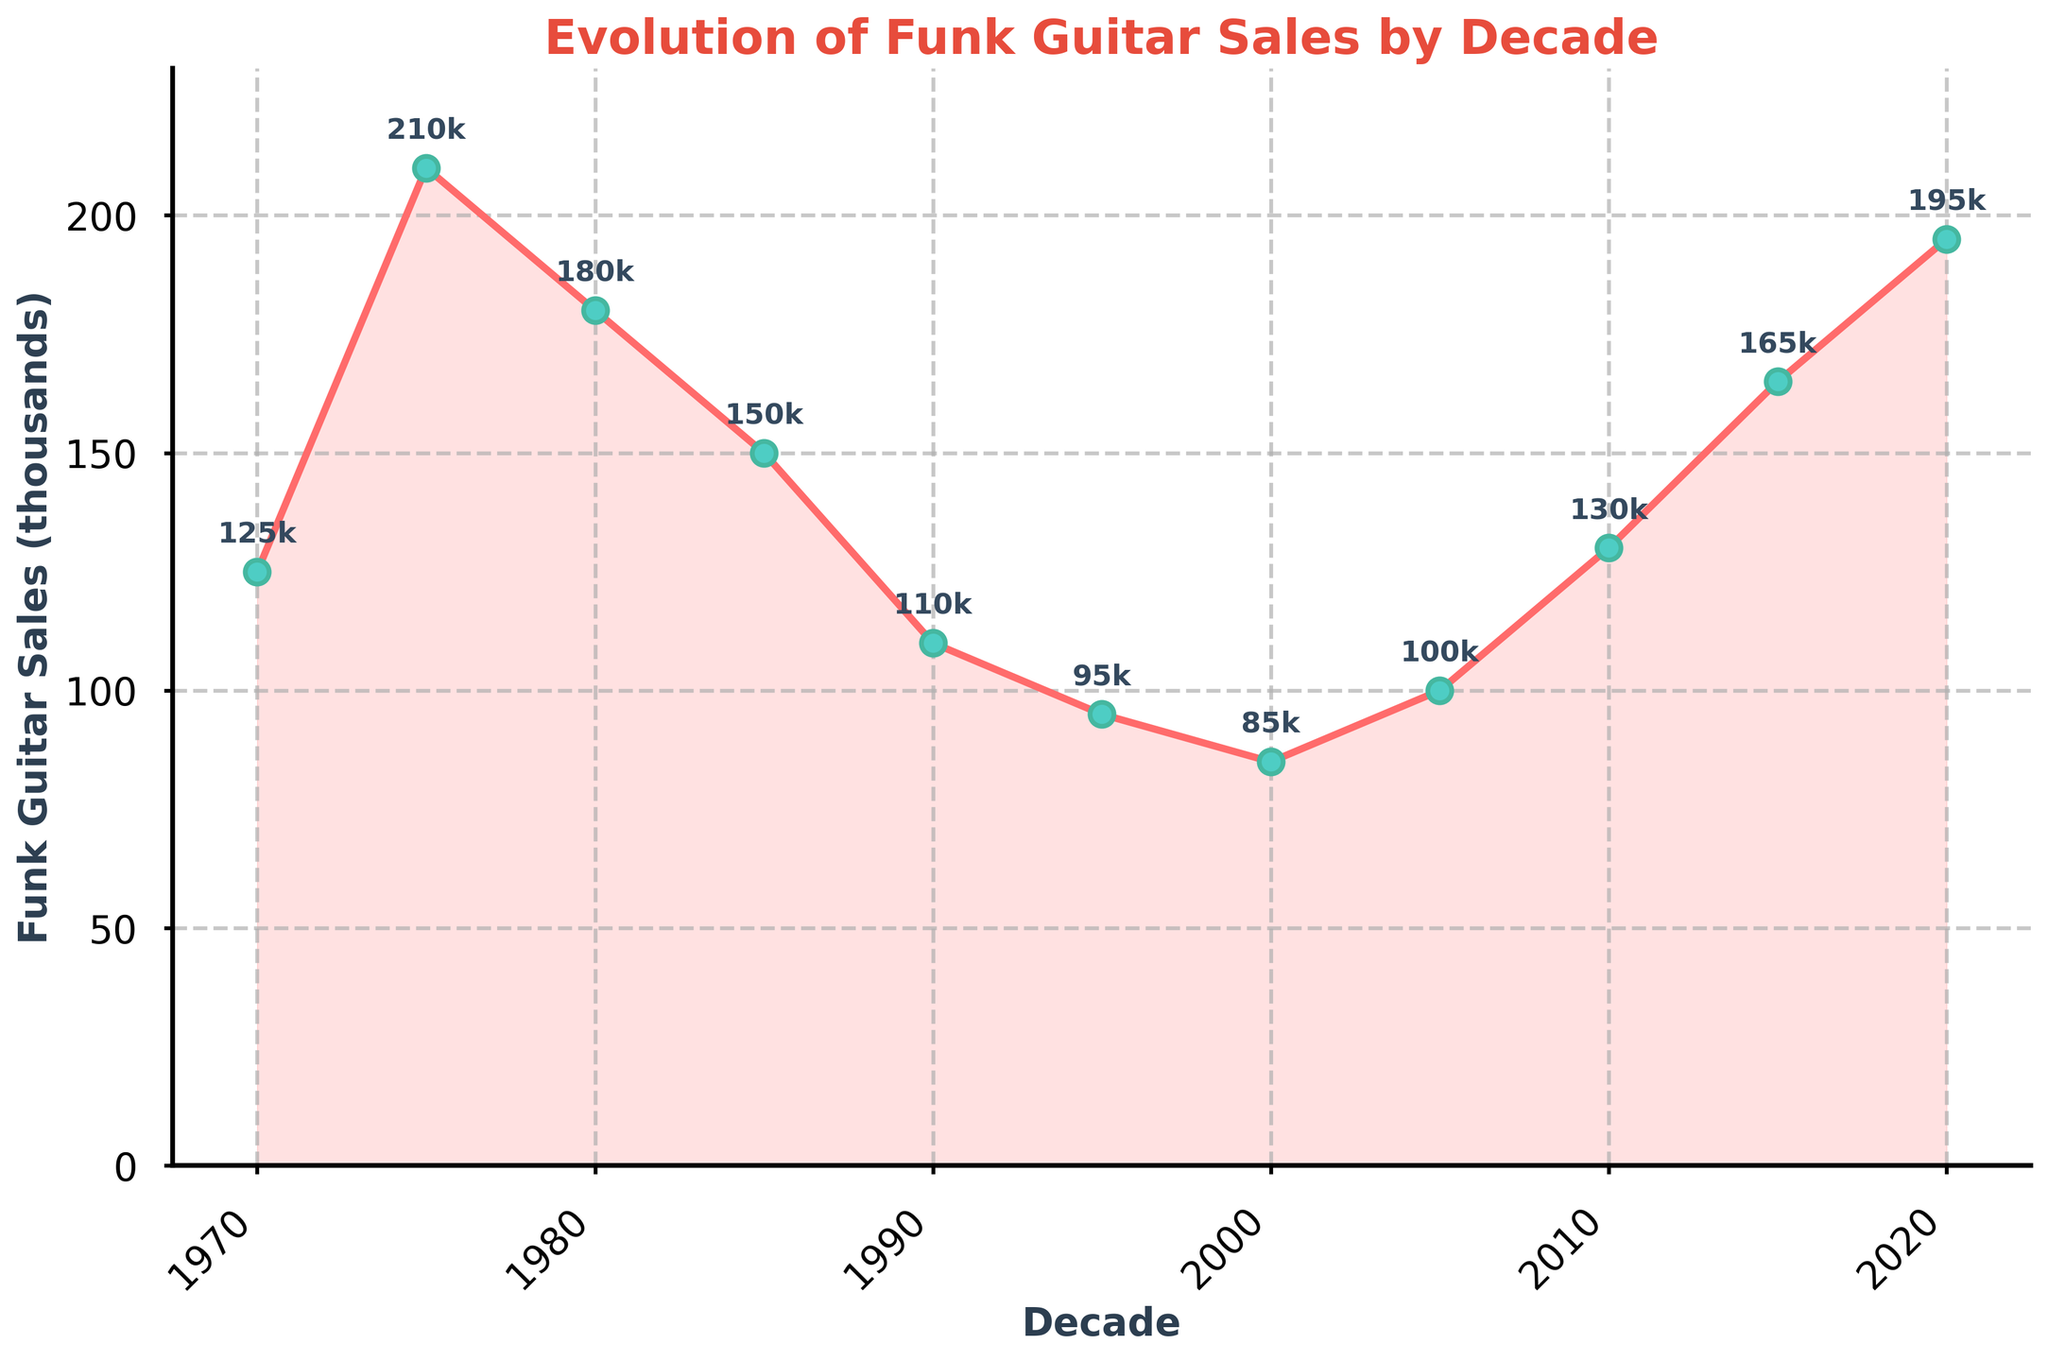What's the general trend of funk guitar sales from 1970 to 2020? By observing the line chart, we can see that funk guitar sales initially rose from the 1970s (125k) to the mid-1970s (210k), then declined through the 1980s to mid-1990s (down to 85k), before gradually rising again towards 2020 (195k). This indicates a rise, followed by a fall, and then a recovery trend.
Answer: Rise, fall, recovery When was the highest spike in funk guitar sales? Observing the individual markers, the highest spike occurred in the mid-1970s with sales reaching 210k.
Answer: Mid-1970s Between which decades did funk guitar sales experience the steepest decline? By comparing the slopes of the line segments, the steepest decline occurs between the mid-1970s (210k) and the mid-1990s (85k).
Answer: Mid-1970s to mid-1990s Which decade saw the lowest sales of funk guitars? The lowest point on the chart is in the year 2000 with sales reaching 85k.
Answer: Year 2000 How do the sales in 2010 compare to those in 1985? By comparing the markers for 2010 (130k) and 1985 (150k), the sales in 2010 are 20k less than in 1985.
Answer: 20k less What is the average sales of funk guitars across all decades shown? To find the average, add all sales values and divide by the number of data points: (125 + 210 + 180 + 150 + 110 + 95 + 85 + 100 + 130 + 165 + 195) / 11 = 137.27k.
Answer: 137.27k Which decade showed a recovery in funk guitar sales after a declining trend? After the year 2000 (85k), sales began to rise again, reaching 130k in 2010, showing a recovery trend.
Answer: After 2000 What is the difference in sales between the peak in the mid-1970s and the lowest point in the year 2000? Sales in the mid-1970s were 210k, and the lowest point in 2000 was 85k. The difference is 210k - 85k = 125k.
Answer: 125k How does the color of the line used in the plot help in understanding the data trend? The bright red line with filled-area shading visually emphasizes the rise, fall, and recovery patterns over decades, making trends easier to spot.
Answer: Highlights trends 